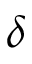Convert formula to latex. <formula><loc_0><loc_0><loc_500><loc_500>\delta</formula> 